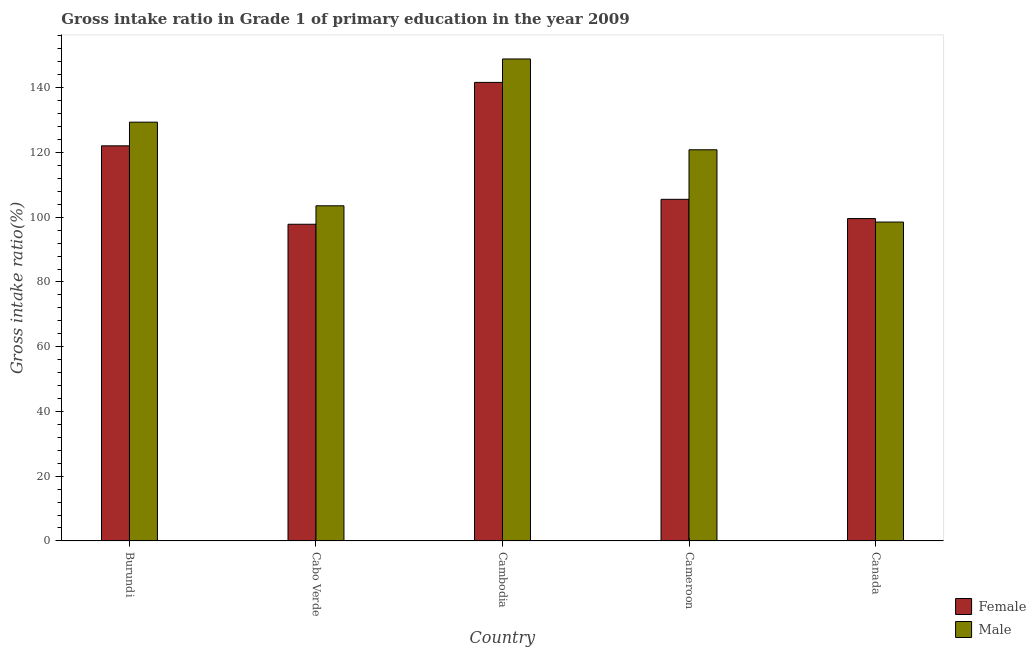How many different coloured bars are there?
Give a very brief answer. 2. Are the number of bars per tick equal to the number of legend labels?
Your answer should be compact. Yes. How many bars are there on the 1st tick from the left?
Offer a terse response. 2. What is the label of the 1st group of bars from the left?
Your answer should be compact. Burundi. What is the gross intake ratio(female) in Cambodia?
Offer a very short reply. 141.66. Across all countries, what is the maximum gross intake ratio(male)?
Your answer should be compact. 148.9. Across all countries, what is the minimum gross intake ratio(male)?
Your response must be concise. 98.51. In which country was the gross intake ratio(female) maximum?
Your answer should be very brief. Cambodia. In which country was the gross intake ratio(female) minimum?
Give a very brief answer. Cabo Verde. What is the total gross intake ratio(female) in the graph?
Your answer should be very brief. 566.68. What is the difference between the gross intake ratio(male) in Cambodia and that in Canada?
Give a very brief answer. 50.39. What is the difference between the gross intake ratio(male) in Cambodia and the gross intake ratio(female) in Canada?
Offer a terse response. 49.31. What is the average gross intake ratio(female) per country?
Give a very brief answer. 113.34. What is the difference between the gross intake ratio(male) and gross intake ratio(female) in Cameroon?
Give a very brief answer. 15.31. In how many countries, is the gross intake ratio(male) greater than 100 %?
Give a very brief answer. 4. What is the ratio of the gross intake ratio(female) in Cabo Verde to that in Cameroon?
Your answer should be very brief. 0.93. Is the difference between the gross intake ratio(male) in Cabo Verde and Canada greater than the difference between the gross intake ratio(female) in Cabo Verde and Canada?
Ensure brevity in your answer.  Yes. What is the difference between the highest and the second highest gross intake ratio(male)?
Your answer should be compact. 19.52. What is the difference between the highest and the lowest gross intake ratio(male)?
Your answer should be compact. 50.39. Is the sum of the gross intake ratio(male) in Burundi and Canada greater than the maximum gross intake ratio(female) across all countries?
Provide a short and direct response. Yes. What does the 2nd bar from the left in Cabo Verde represents?
Give a very brief answer. Male. How many countries are there in the graph?
Offer a terse response. 5. What is the difference between two consecutive major ticks on the Y-axis?
Make the answer very short. 20. Does the graph contain any zero values?
Make the answer very short. No. Does the graph contain grids?
Provide a succinct answer. No. How many legend labels are there?
Provide a short and direct response. 2. What is the title of the graph?
Offer a very short reply. Gross intake ratio in Grade 1 of primary education in the year 2009. What is the label or title of the Y-axis?
Provide a short and direct response. Gross intake ratio(%). What is the Gross intake ratio(%) of Female in Burundi?
Keep it short and to the point. 122.06. What is the Gross intake ratio(%) in Male in Burundi?
Provide a short and direct response. 129.37. What is the Gross intake ratio(%) in Female in Cabo Verde?
Offer a terse response. 97.83. What is the Gross intake ratio(%) of Male in Cabo Verde?
Your answer should be compact. 103.54. What is the Gross intake ratio(%) in Female in Cambodia?
Give a very brief answer. 141.66. What is the Gross intake ratio(%) in Male in Cambodia?
Provide a succinct answer. 148.9. What is the Gross intake ratio(%) in Female in Cameroon?
Your answer should be very brief. 105.54. What is the Gross intake ratio(%) of Male in Cameroon?
Your answer should be very brief. 120.85. What is the Gross intake ratio(%) in Female in Canada?
Make the answer very short. 99.59. What is the Gross intake ratio(%) in Male in Canada?
Ensure brevity in your answer.  98.51. Across all countries, what is the maximum Gross intake ratio(%) in Female?
Your response must be concise. 141.66. Across all countries, what is the maximum Gross intake ratio(%) of Male?
Give a very brief answer. 148.9. Across all countries, what is the minimum Gross intake ratio(%) in Female?
Your answer should be very brief. 97.83. Across all countries, what is the minimum Gross intake ratio(%) of Male?
Keep it short and to the point. 98.51. What is the total Gross intake ratio(%) of Female in the graph?
Your response must be concise. 566.68. What is the total Gross intake ratio(%) of Male in the graph?
Ensure brevity in your answer.  601.16. What is the difference between the Gross intake ratio(%) in Female in Burundi and that in Cabo Verde?
Ensure brevity in your answer.  24.23. What is the difference between the Gross intake ratio(%) of Male in Burundi and that in Cabo Verde?
Your response must be concise. 25.84. What is the difference between the Gross intake ratio(%) in Female in Burundi and that in Cambodia?
Keep it short and to the point. -19.6. What is the difference between the Gross intake ratio(%) in Male in Burundi and that in Cambodia?
Your answer should be compact. -19.52. What is the difference between the Gross intake ratio(%) of Female in Burundi and that in Cameroon?
Provide a succinct answer. 16.52. What is the difference between the Gross intake ratio(%) of Male in Burundi and that in Cameroon?
Your response must be concise. 8.53. What is the difference between the Gross intake ratio(%) of Female in Burundi and that in Canada?
Your answer should be compact. 22.47. What is the difference between the Gross intake ratio(%) in Male in Burundi and that in Canada?
Your response must be concise. 30.86. What is the difference between the Gross intake ratio(%) in Female in Cabo Verde and that in Cambodia?
Ensure brevity in your answer.  -43.83. What is the difference between the Gross intake ratio(%) of Male in Cabo Verde and that in Cambodia?
Make the answer very short. -45.36. What is the difference between the Gross intake ratio(%) of Female in Cabo Verde and that in Cameroon?
Ensure brevity in your answer.  -7.71. What is the difference between the Gross intake ratio(%) of Male in Cabo Verde and that in Cameroon?
Offer a terse response. -17.31. What is the difference between the Gross intake ratio(%) of Female in Cabo Verde and that in Canada?
Your response must be concise. -1.76. What is the difference between the Gross intake ratio(%) in Male in Cabo Verde and that in Canada?
Your response must be concise. 5.03. What is the difference between the Gross intake ratio(%) in Female in Cambodia and that in Cameroon?
Your answer should be compact. 36.12. What is the difference between the Gross intake ratio(%) in Male in Cambodia and that in Cameroon?
Keep it short and to the point. 28.05. What is the difference between the Gross intake ratio(%) in Female in Cambodia and that in Canada?
Ensure brevity in your answer.  42.07. What is the difference between the Gross intake ratio(%) in Male in Cambodia and that in Canada?
Make the answer very short. 50.38. What is the difference between the Gross intake ratio(%) of Female in Cameroon and that in Canada?
Offer a very short reply. 5.95. What is the difference between the Gross intake ratio(%) of Male in Cameroon and that in Canada?
Make the answer very short. 22.33. What is the difference between the Gross intake ratio(%) in Female in Burundi and the Gross intake ratio(%) in Male in Cabo Verde?
Provide a succinct answer. 18.52. What is the difference between the Gross intake ratio(%) in Female in Burundi and the Gross intake ratio(%) in Male in Cambodia?
Your response must be concise. -26.84. What is the difference between the Gross intake ratio(%) in Female in Burundi and the Gross intake ratio(%) in Male in Cameroon?
Give a very brief answer. 1.22. What is the difference between the Gross intake ratio(%) of Female in Burundi and the Gross intake ratio(%) of Male in Canada?
Your response must be concise. 23.55. What is the difference between the Gross intake ratio(%) of Female in Cabo Verde and the Gross intake ratio(%) of Male in Cambodia?
Offer a terse response. -51.06. What is the difference between the Gross intake ratio(%) in Female in Cabo Verde and the Gross intake ratio(%) in Male in Cameroon?
Keep it short and to the point. -23.01. What is the difference between the Gross intake ratio(%) of Female in Cabo Verde and the Gross intake ratio(%) of Male in Canada?
Keep it short and to the point. -0.68. What is the difference between the Gross intake ratio(%) of Female in Cambodia and the Gross intake ratio(%) of Male in Cameroon?
Provide a short and direct response. 20.81. What is the difference between the Gross intake ratio(%) in Female in Cambodia and the Gross intake ratio(%) in Male in Canada?
Make the answer very short. 43.15. What is the difference between the Gross intake ratio(%) in Female in Cameroon and the Gross intake ratio(%) in Male in Canada?
Offer a terse response. 7.03. What is the average Gross intake ratio(%) in Female per country?
Your answer should be very brief. 113.34. What is the average Gross intake ratio(%) of Male per country?
Your answer should be compact. 120.23. What is the difference between the Gross intake ratio(%) in Female and Gross intake ratio(%) in Male in Burundi?
Provide a short and direct response. -7.31. What is the difference between the Gross intake ratio(%) of Female and Gross intake ratio(%) of Male in Cabo Verde?
Your answer should be very brief. -5.71. What is the difference between the Gross intake ratio(%) in Female and Gross intake ratio(%) in Male in Cambodia?
Give a very brief answer. -7.24. What is the difference between the Gross intake ratio(%) in Female and Gross intake ratio(%) in Male in Cameroon?
Provide a succinct answer. -15.31. What is the difference between the Gross intake ratio(%) in Female and Gross intake ratio(%) in Male in Canada?
Make the answer very short. 1.08. What is the ratio of the Gross intake ratio(%) in Female in Burundi to that in Cabo Verde?
Provide a succinct answer. 1.25. What is the ratio of the Gross intake ratio(%) of Male in Burundi to that in Cabo Verde?
Keep it short and to the point. 1.25. What is the ratio of the Gross intake ratio(%) of Female in Burundi to that in Cambodia?
Offer a terse response. 0.86. What is the ratio of the Gross intake ratio(%) of Male in Burundi to that in Cambodia?
Provide a short and direct response. 0.87. What is the ratio of the Gross intake ratio(%) in Female in Burundi to that in Cameroon?
Ensure brevity in your answer.  1.16. What is the ratio of the Gross intake ratio(%) in Male in Burundi to that in Cameroon?
Your response must be concise. 1.07. What is the ratio of the Gross intake ratio(%) of Female in Burundi to that in Canada?
Provide a succinct answer. 1.23. What is the ratio of the Gross intake ratio(%) of Male in Burundi to that in Canada?
Offer a very short reply. 1.31. What is the ratio of the Gross intake ratio(%) in Female in Cabo Verde to that in Cambodia?
Your response must be concise. 0.69. What is the ratio of the Gross intake ratio(%) of Male in Cabo Verde to that in Cambodia?
Your answer should be compact. 0.7. What is the ratio of the Gross intake ratio(%) of Female in Cabo Verde to that in Cameroon?
Provide a short and direct response. 0.93. What is the ratio of the Gross intake ratio(%) of Male in Cabo Verde to that in Cameroon?
Keep it short and to the point. 0.86. What is the ratio of the Gross intake ratio(%) in Female in Cabo Verde to that in Canada?
Your answer should be compact. 0.98. What is the ratio of the Gross intake ratio(%) of Male in Cabo Verde to that in Canada?
Make the answer very short. 1.05. What is the ratio of the Gross intake ratio(%) of Female in Cambodia to that in Cameroon?
Your response must be concise. 1.34. What is the ratio of the Gross intake ratio(%) in Male in Cambodia to that in Cameroon?
Make the answer very short. 1.23. What is the ratio of the Gross intake ratio(%) of Female in Cambodia to that in Canada?
Offer a very short reply. 1.42. What is the ratio of the Gross intake ratio(%) of Male in Cambodia to that in Canada?
Offer a very short reply. 1.51. What is the ratio of the Gross intake ratio(%) of Female in Cameroon to that in Canada?
Offer a very short reply. 1.06. What is the ratio of the Gross intake ratio(%) of Male in Cameroon to that in Canada?
Keep it short and to the point. 1.23. What is the difference between the highest and the second highest Gross intake ratio(%) of Female?
Keep it short and to the point. 19.6. What is the difference between the highest and the second highest Gross intake ratio(%) of Male?
Your response must be concise. 19.52. What is the difference between the highest and the lowest Gross intake ratio(%) of Female?
Offer a very short reply. 43.83. What is the difference between the highest and the lowest Gross intake ratio(%) in Male?
Offer a very short reply. 50.38. 